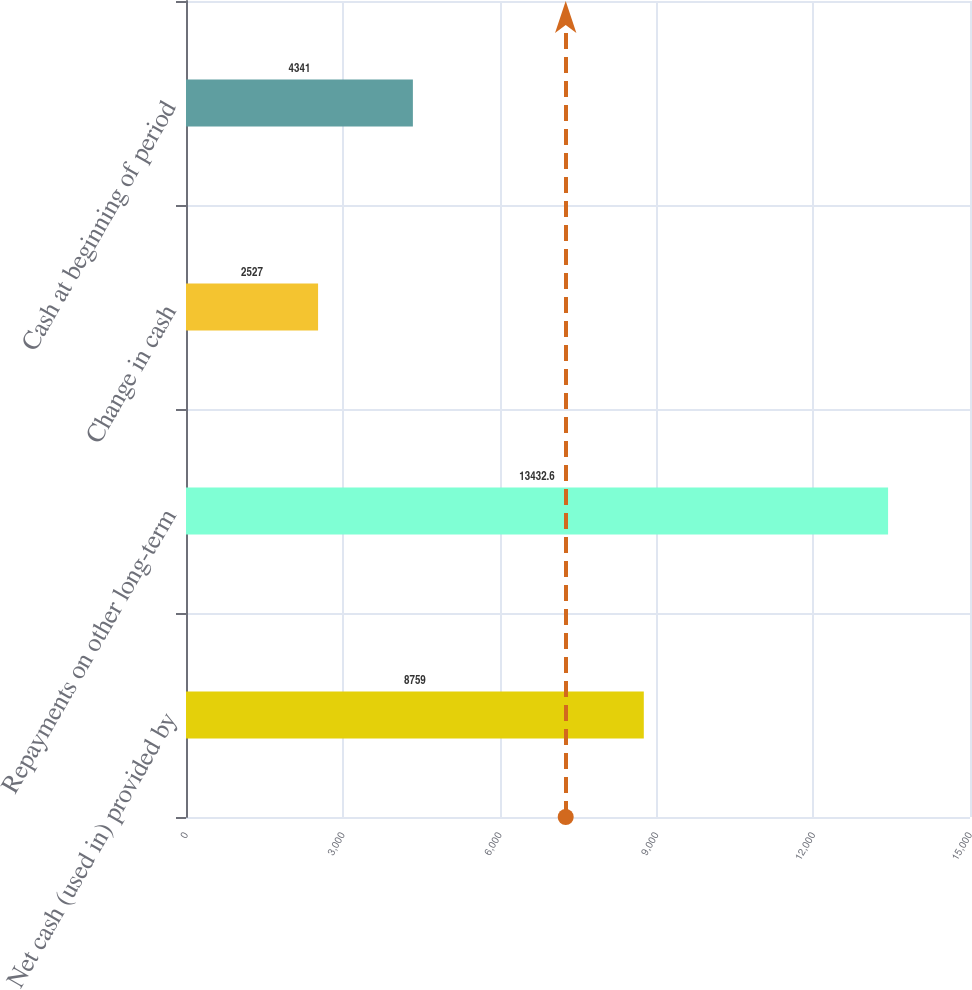<chart> <loc_0><loc_0><loc_500><loc_500><bar_chart><fcel>Net cash (used in) provided by<fcel>Repayments on other long-term<fcel>Change in cash<fcel>Cash at beginning of period<nl><fcel>8759<fcel>13432.6<fcel>2527<fcel>4341<nl></chart> 